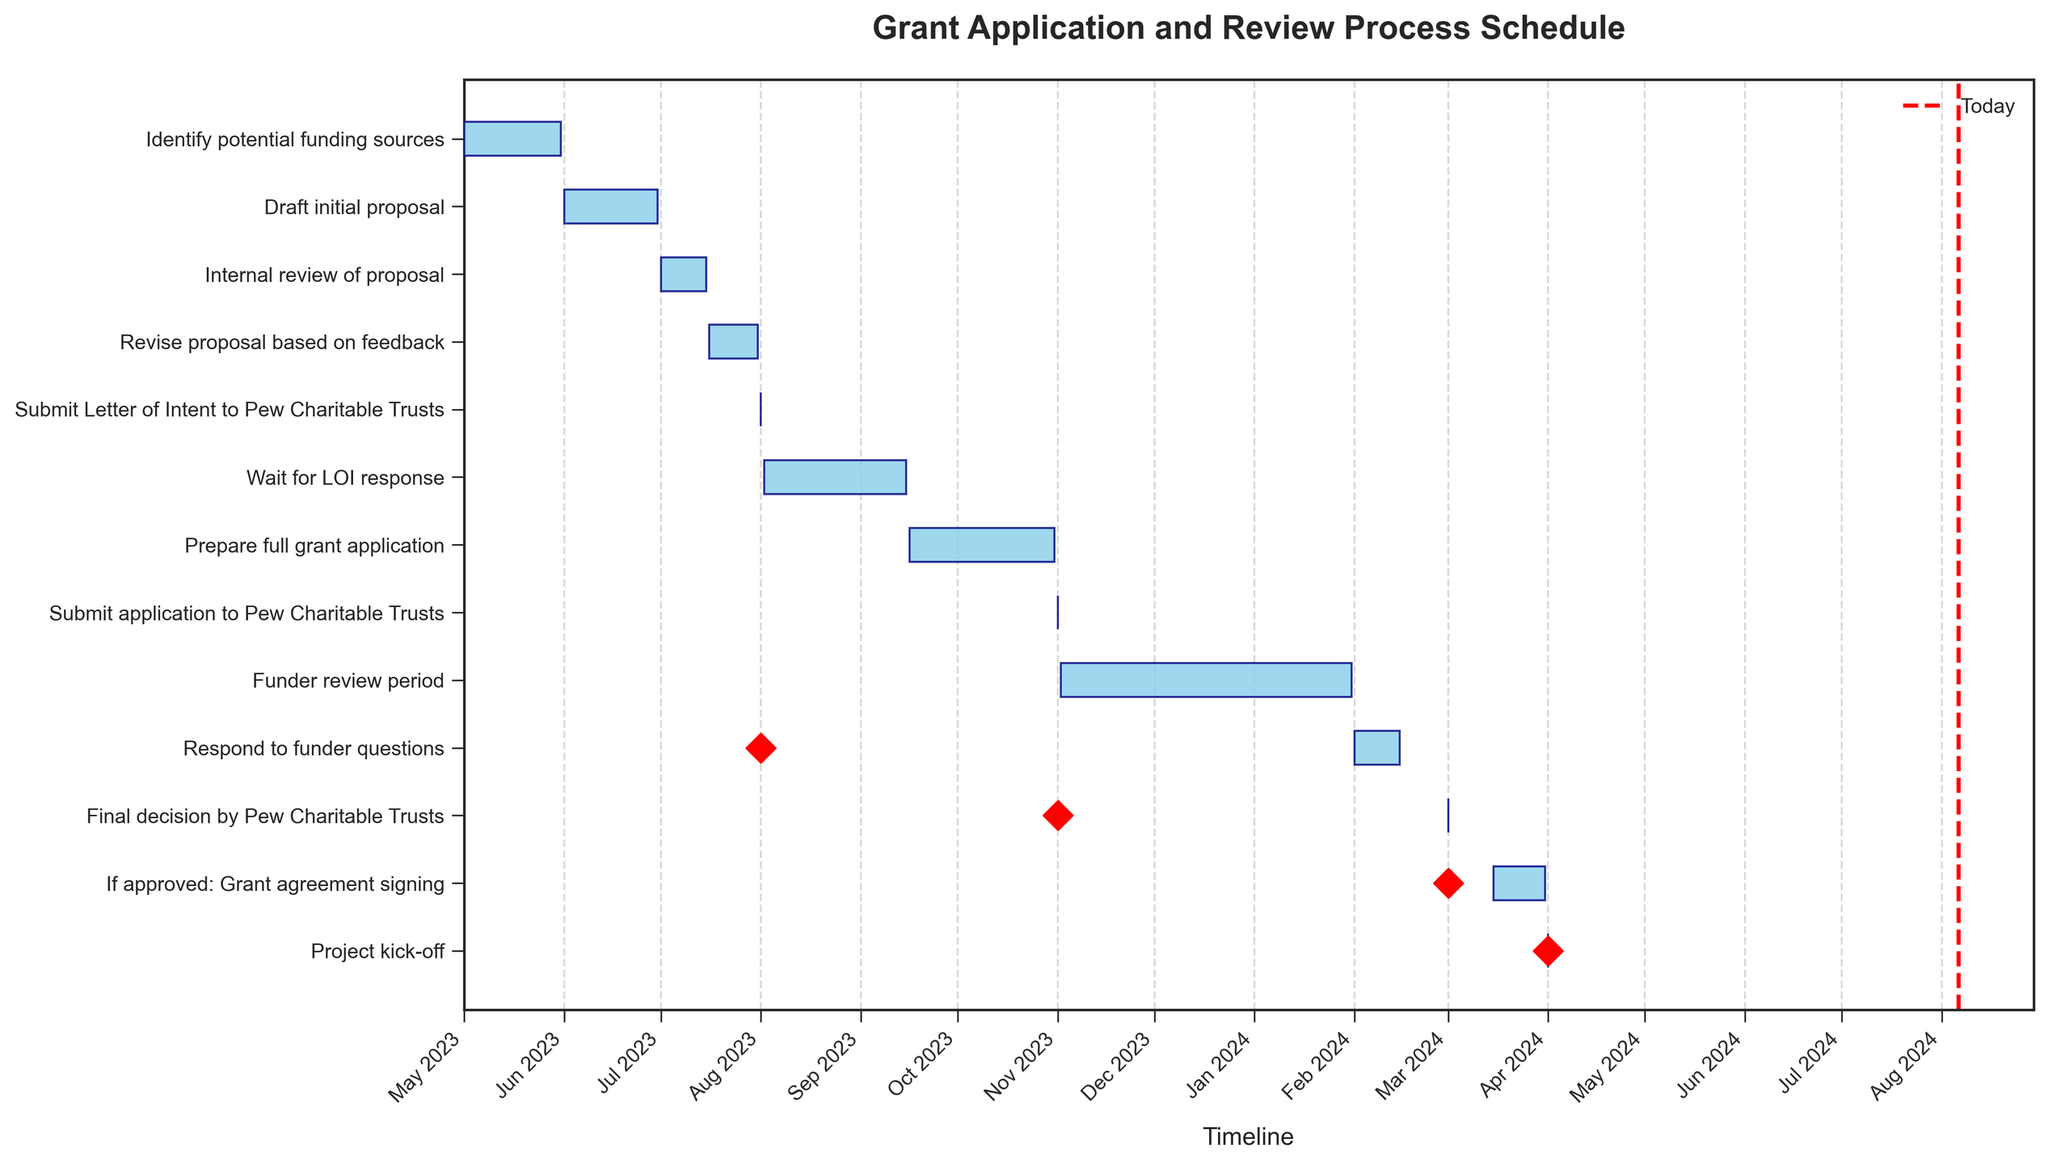When does the "Prepare full grant application" task start and end? The "Prepare full grant application" task spans from September 16, 2023, to October 31, 2023. These dates can be seen on the horizontal bar that represents this task in the Gantt chart.
Answer: September 16, 2023, to October 31, 2023 How many days are allocated for internal review of the proposal? The "Internal review of proposal" task lasts from July 1, 2023, to July 15, 2023. The difference between these two dates is 14 days.
Answer: 14 days What is the total time period from the start of "Identify potential funding sources" to the "Final decision by Pew Charitable Trusts"? The earliest start date is May 1, 2023, from "Identify potential funding sources," and the "Final decision by Pew Charitable Trusts" is on March 1, 2024. The total time span covers from May 1, 2023, to March 1, 2024.
Answer: May 1, 2023, to March 1, 2024 Which task has the shortest duration and what is its timeframe? The "Submit Letter of Intent to Pew Charitable Trusts" task has the shortest duration, as it starts and ends on August 1, 2023.
Answer: August 1, 2023 Which tasks have start and end dates on the same day? The "Submit Letter of Intent to Pew Charitable Trusts," "Submit application to Pew Charitable Trusts," "Final decision by Pew Charitable Trusts," and "Project kick-off" all have start and end dates on the same day.
Answer: Submit Letter of Intent to Pew Charitable Trusts, Submit application to Pew Charitable Trusts, Final decision by Pew Charitable Trusts, Project kick-off What is the combined duration for the "Revise proposal based on feedback" and "Prepare full grant application" tasks? The duration for "Revise proposal based on feedback" is from July 16, 2023, to July 31, 2023, which is 15 days, and the duration for "Prepare full grant application" is from September 16, 2023, to October 31, 2023, which is 46 days. Adding these gives a combined duration of 15 + 46 = 61 days.
Answer: 61 days Compare the durations of "Funder review period" and "Respond to funder questions." Which one is longer and by how many days? The "Funder review period" lasts from November 2, 2023, to January 31, 2024, which is 91 days, while "Respond to funder questions" lasts from February 1, 2024, to February 15, 2024, which is 15 days. "Funder review period" is longer by 91 - 15 = 76 days.
Answer: Funder review period by 76 days What is the total duration from submitting the application to receiving the final decision? The "Submit application to Pew Charitable Trusts" is on November 1, 2023, and the "Final decision by Pew Charitable Trusts" is on March 1, 2024. The duration between these dates is exactly 120 days.
Answer: 120 days Identify the task that starts immediately after the "Revise proposal based on feedback" task. The task "Submit Letter of Intent to Pew Charitable Trusts" starts immediately after the "Revise proposal based on feedback" task, beginning on August 1, 2023.
Answer: Submit Letter of Intent to Pew Charitable Trusts 